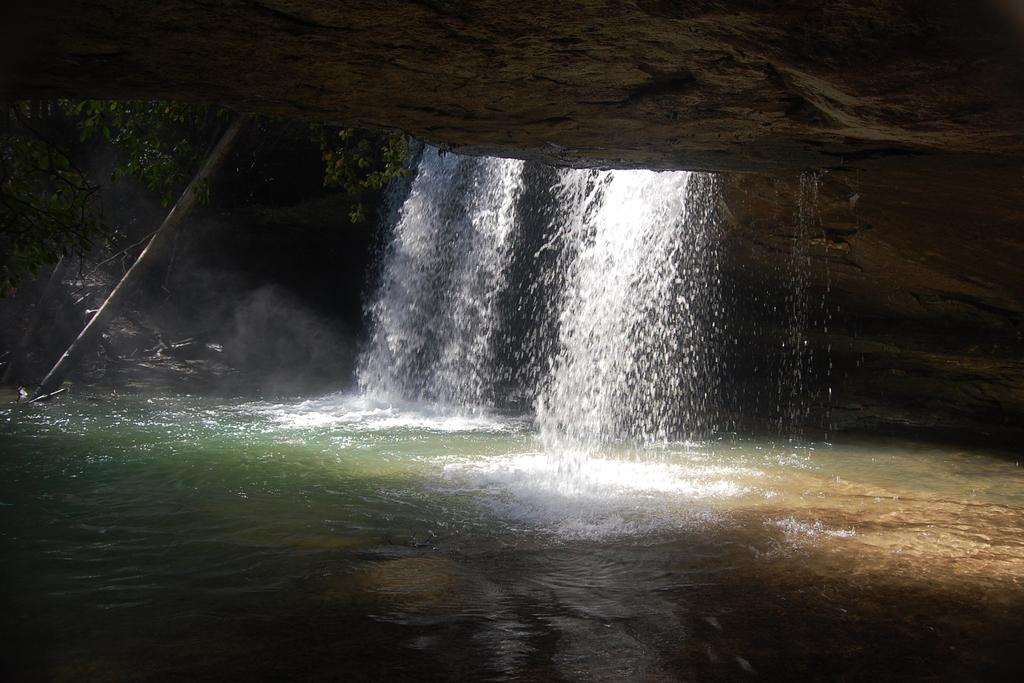What is happening in the image? There is water falling in the image. Can you describe the water in the image? There is water visible in the image. What type of steel is used to make the scarf in the image? There is no scarf present in the image, and therefore no steel can be associated with it. 